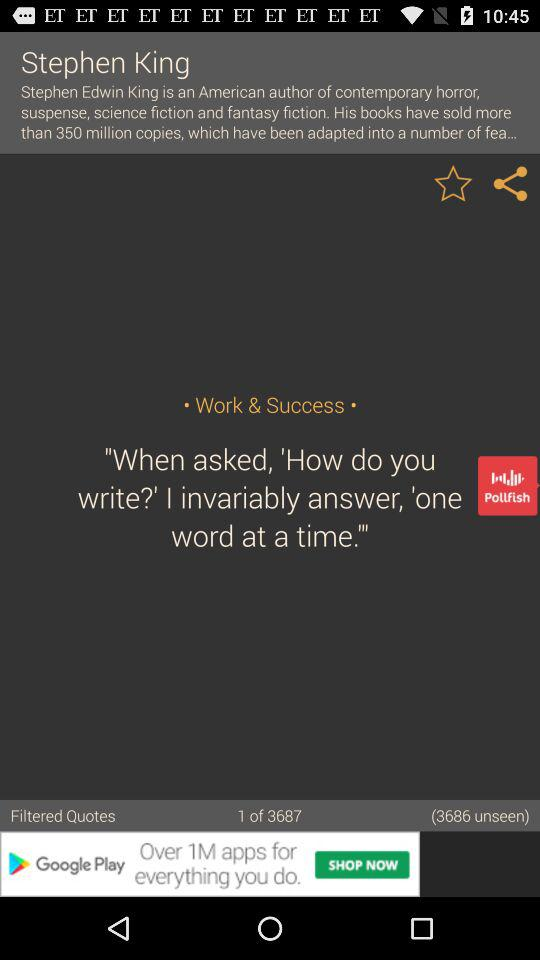How many more unseen quotes are there than seen quotes?
Answer the question using a single word or phrase. 3686 